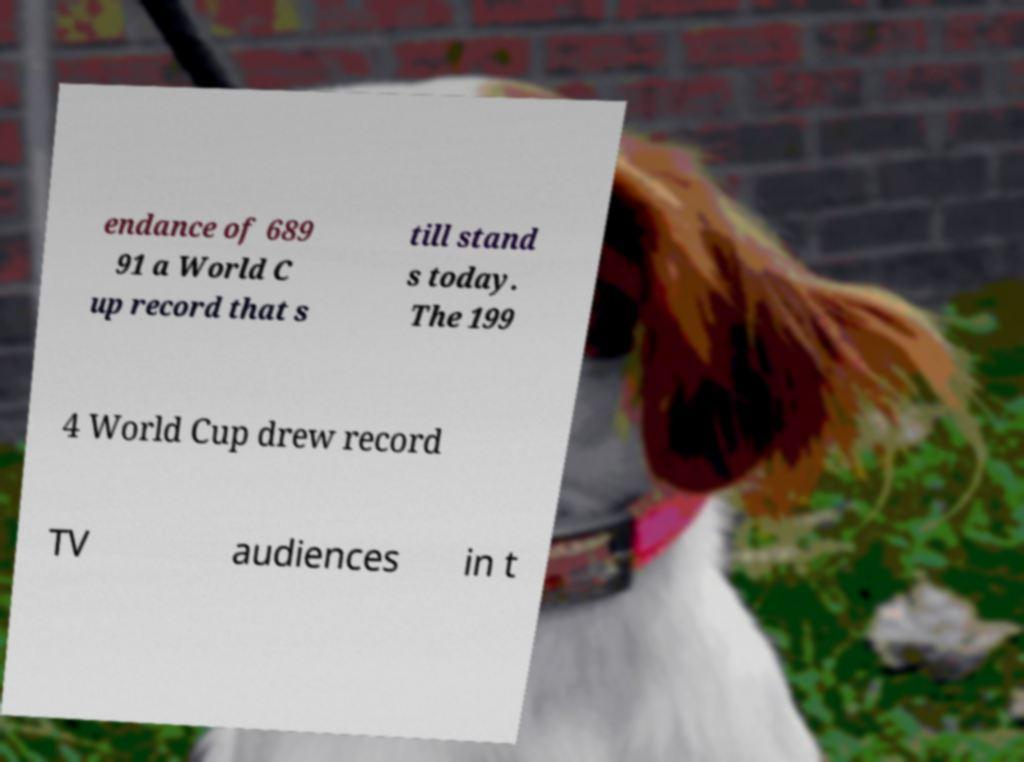Could you assist in decoding the text presented in this image and type it out clearly? endance of 689 91 a World C up record that s till stand s today. The 199 4 World Cup drew record TV audiences in t 